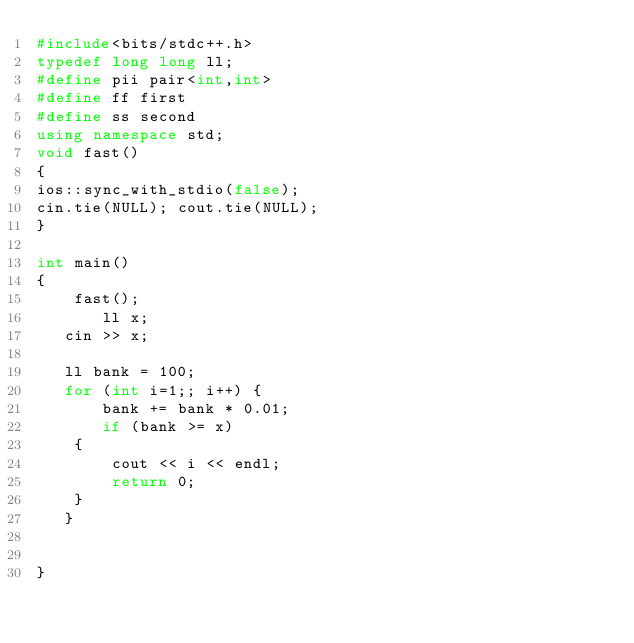<code> <loc_0><loc_0><loc_500><loc_500><_C++_>#include<bits/stdc++.h>
typedef long long ll;
#define pii pair<int,int>
#define ff first
#define ss second
using namespace std;
void fast()
{
ios::sync_with_stdio(false);
cin.tie(NULL); cout.tie(NULL);
}

int main()
{
    fast();
       ll x;
   cin >> x;

   ll bank = 100;
   for (int i=1;; i++) {
       bank += bank * 0.01;
       if (bank >= x)
    {
        cout << i << endl;
        return 0;
    }
   }


}</code> 